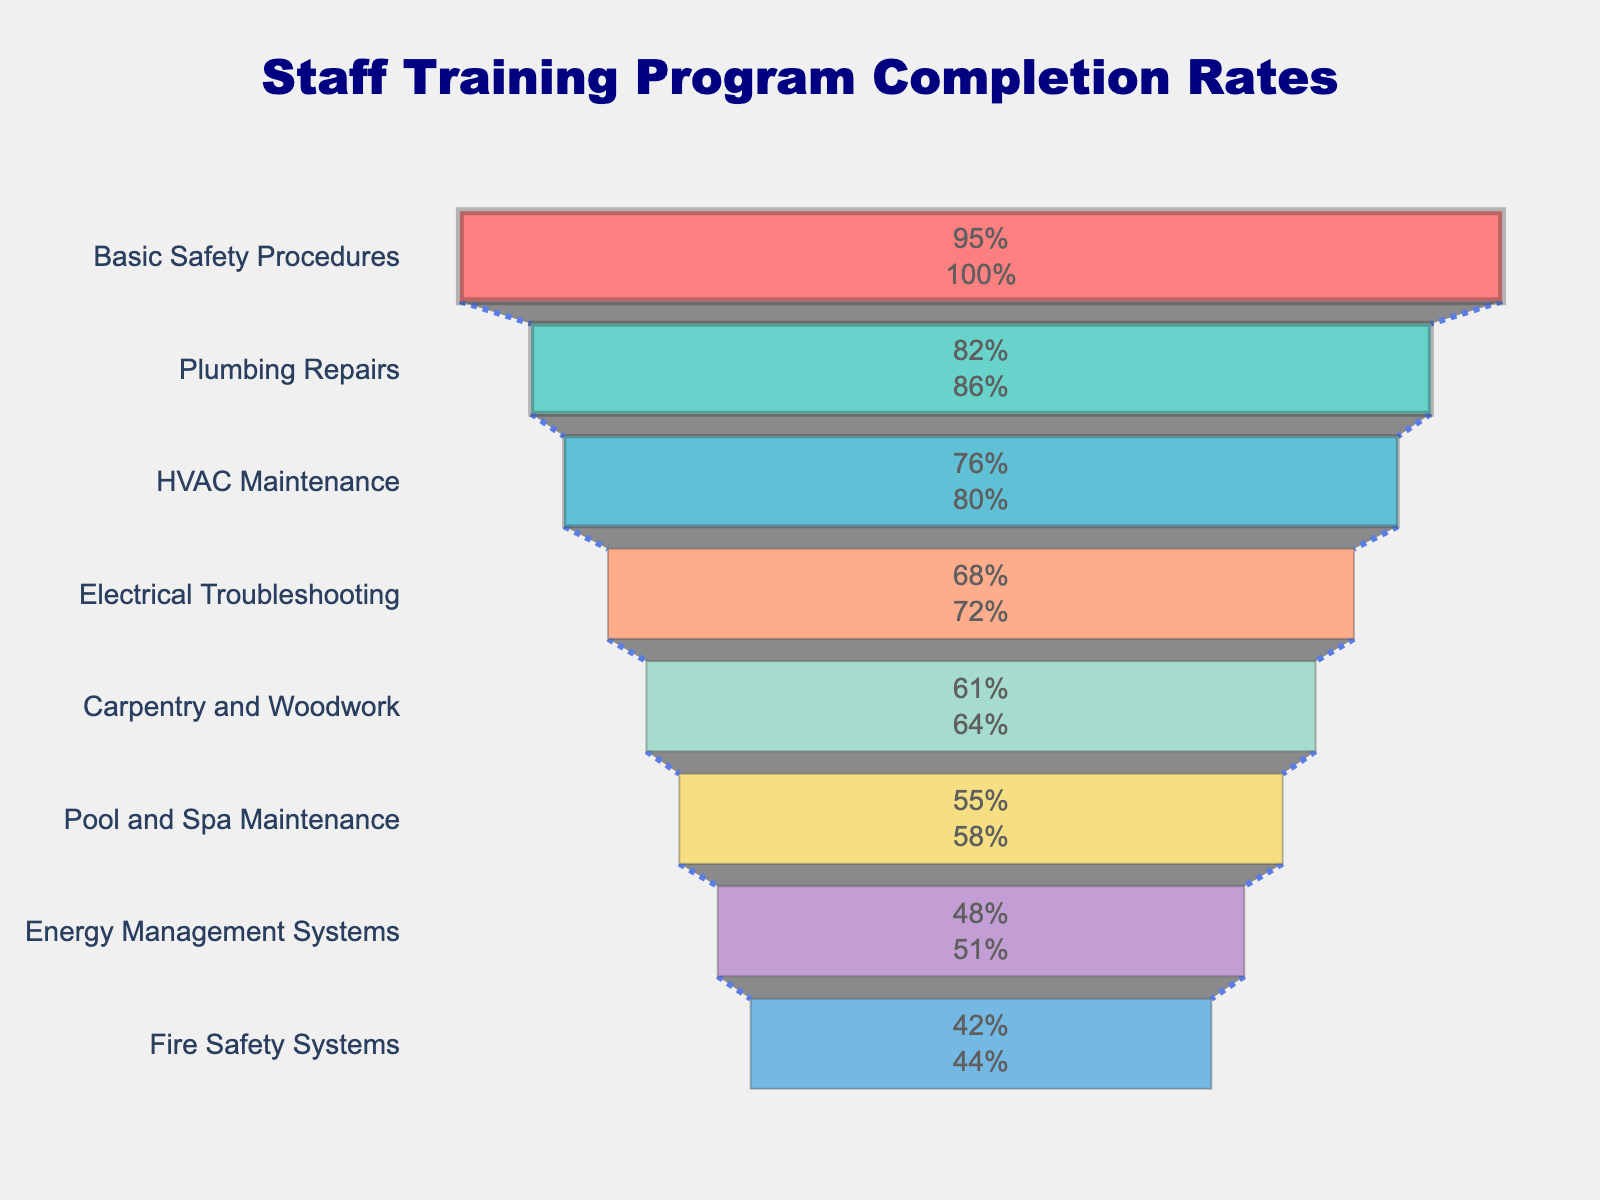How many skills are listed in the funnel chart? Count the number of distinct skills mentioned in the figure. The chart lists eight data points.
Answer: 8 What is the completion rate for Fire Safety Systems? Locate Fire Safety Systems on the vertical axis and read its corresponding completion rate on the horizontal axis. It shows 42%.
Answer: 42% Which skill has the highest completion rate? Identify the skill that appears at the top of the funnel chart. Basic Safety Procedures is listed first with a completion rate of 95%.
Answer: Basic Safety Procedures How much is the difference in completion rates between Plumbing Repairs and HVAC Maintenance? Find the completion rates of both skills (Plumbing Repairs: 82%, HVAC Maintenance: 76%) and calculate the difference: 82 - 76.
Answer: 6% Which skill has the lowest completion rate? Identify the skill that is at the bottom of the funnel. Pool and Spa Maintenance is the last one listed with a rate of 55%.
Answer: Fire Safety Systems What is the average completion rate of the listed skills? Add up all the completion rates and divide by the number of skills: (95 + 82 + 76 + 68 + 61 + 55 + 48 + 42) / 8. This calculation yields 65.875.
Answer: 65.875% Is the completion rate for Electrical Troubleshooting higher than for Carpentry and Woodwork? Compare the completion rates: Electrical Troubleshooting is 68%, Carpentry and Woodwork is 61%. 68 is greater than 61.
Answer: Yes What percentage of skills have a completion rate of 70% or higher? Count the skills with completion rates 70% or more (Basic Safety Procedures, Plumbing Repairs) and then calculate this as a percentage of the total number of skills. 2 out of 8 equals 25%.
Answer: 25% How does the completion rate for Energy Management Systems compare with the median completion rate of all skills? First, list the completion rates in order: 42, 48, 55, 61, 68, 76, 82, 95. The median (middle) value for 8 points is the average of the 4th and 5th values: (61 + 68) / 2 = 64.5. Energy Management Systems has a rate of 48%, which is lower.
Answer: Lower 